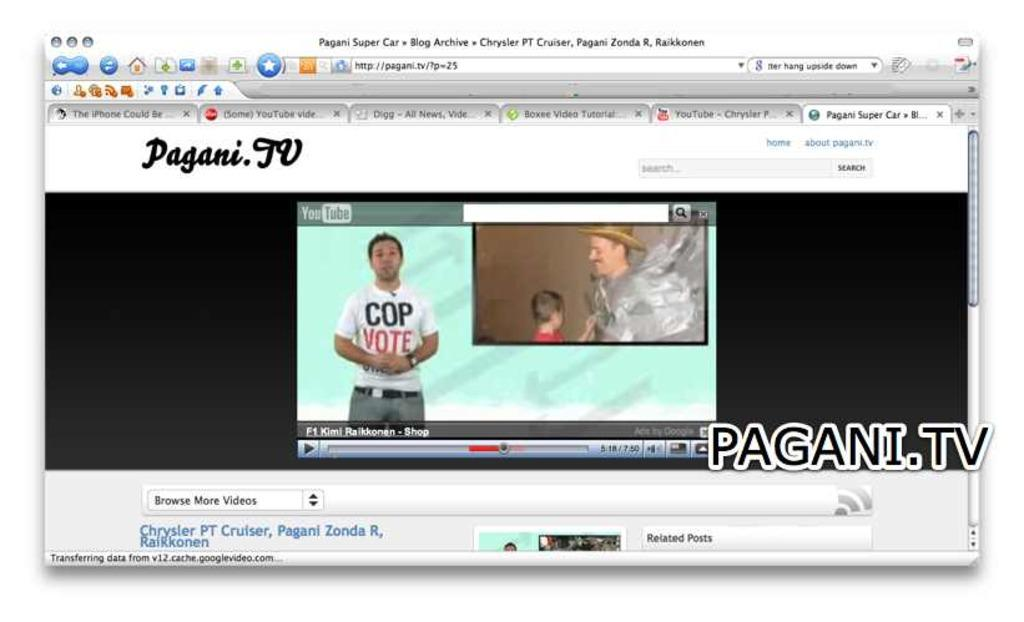What is the main subject of the image? The image is a screenshot of a screen, displaying a website page. What can be seen on the website page? The website page has different options and a video being displayed. What type of content is being shown on the website? The website page contains options and a video, suggesting it might be a video-sharing or streaming platform. What type of shoes are being worn by the person in the video? There is no person visible in the image, and the screenshot does not show any shoes. 